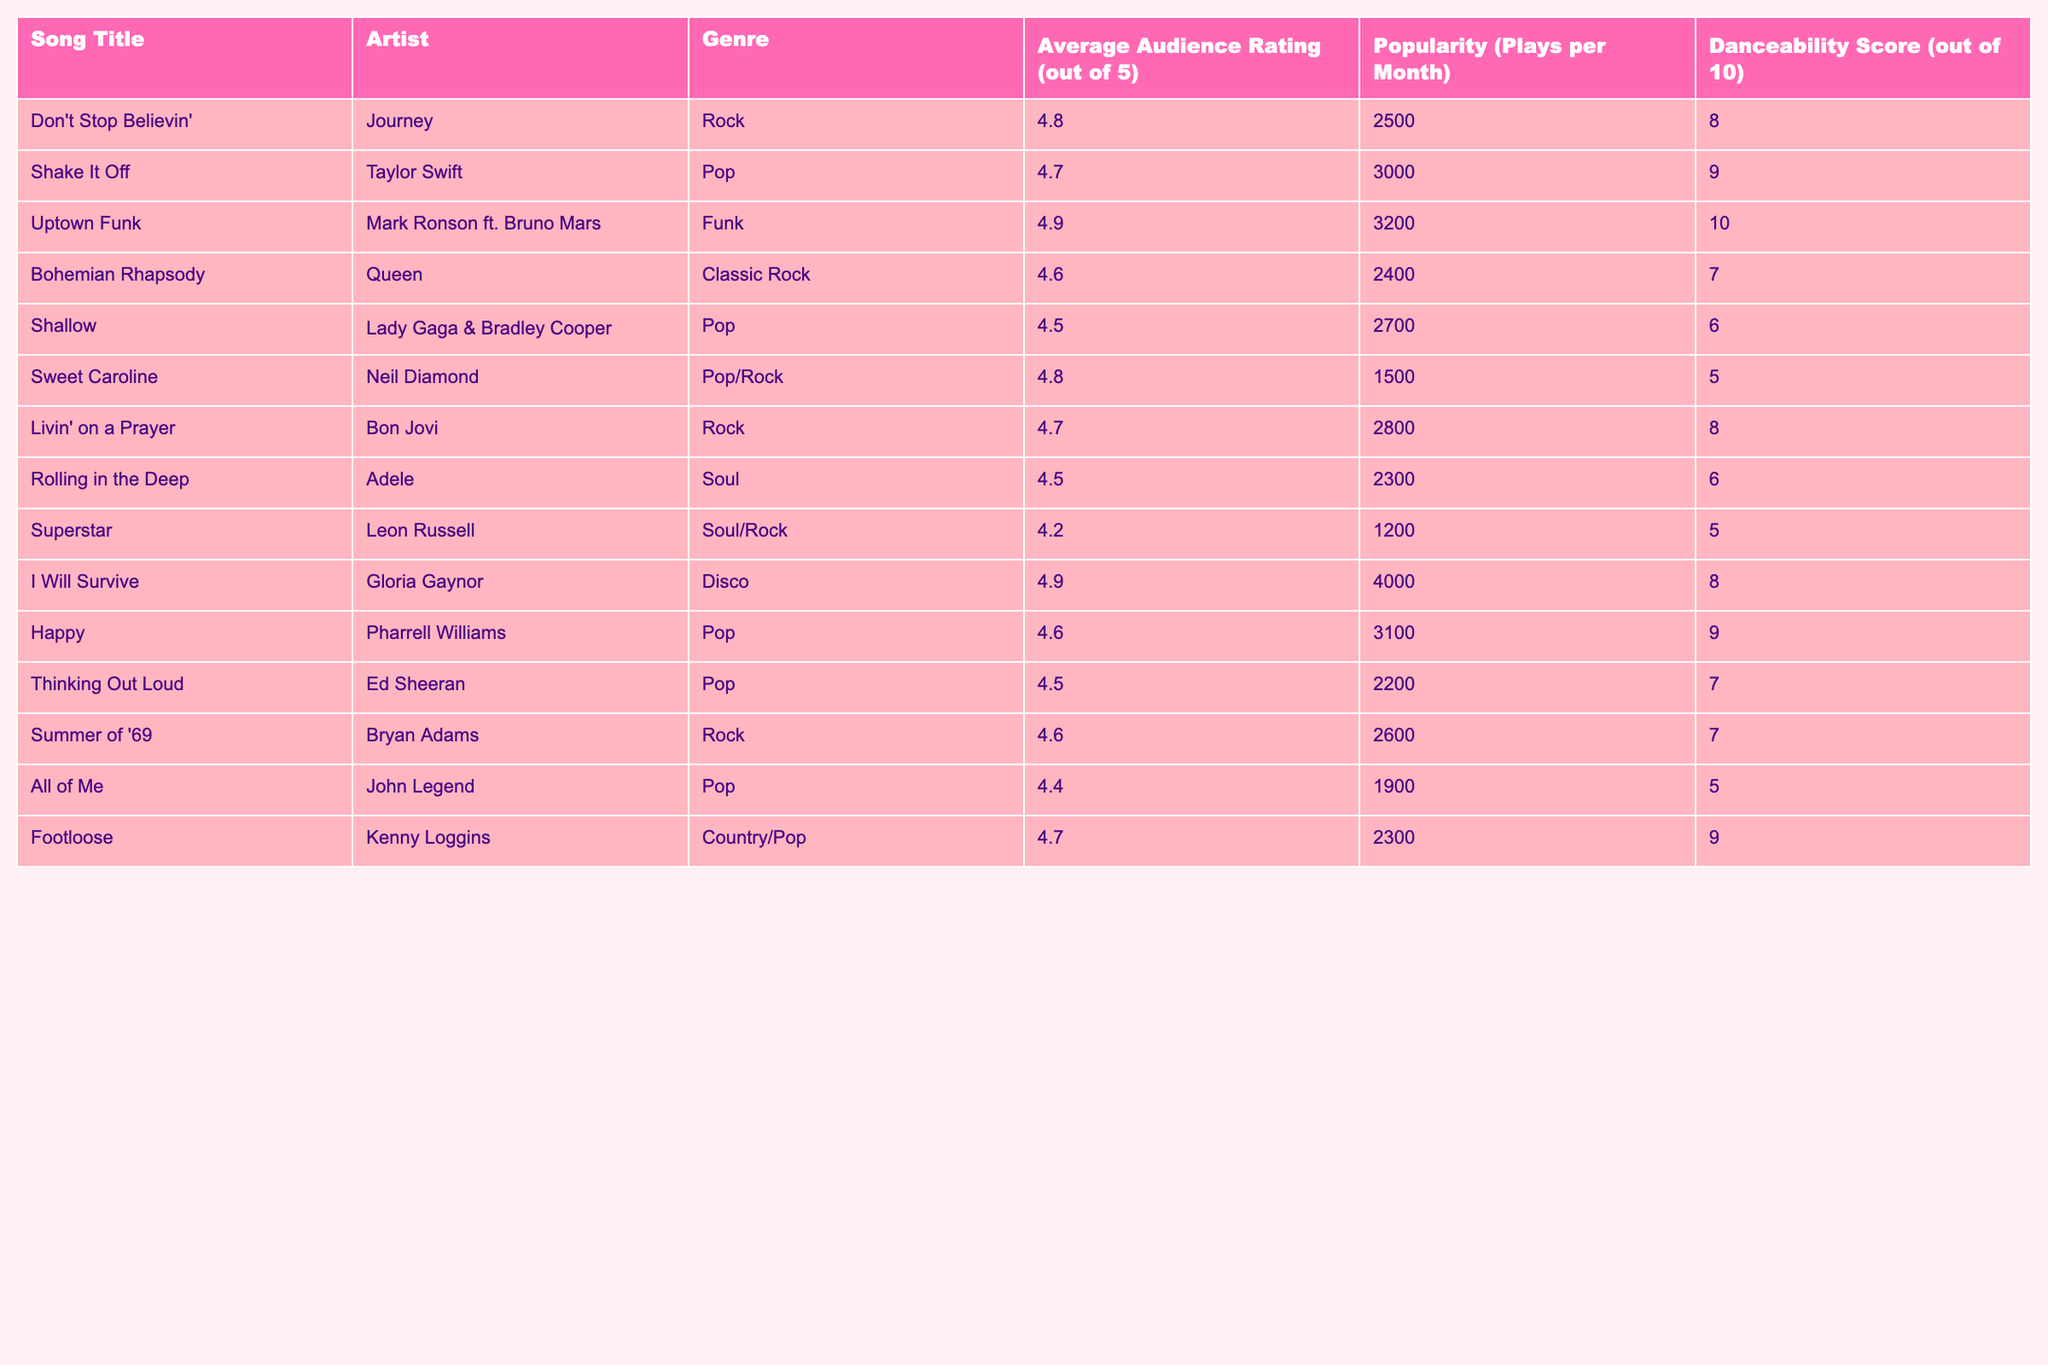What is the average audience rating for "Uptown Funk"? The audience rating for "Uptown Funk" is found under the "Average Audience Rating" column. The value listed is 4.9.
Answer: 4.9 Which song has the highest Danceability Score? In the "Danceability Score" column, "Uptown Funk" has the highest score of 10, which is greater than all other songs listed.
Answer: Uptown Funk What is the total Average Audience Rating for songs in the Pop genre? The Average Audience Ratings for Pop songs are 4.7 ("Shake It Off"), 4.5 ("Shallow"), 4.6 ("Happy"), 4.5 ("Thinking Out Loud"), and 4.4 ("All of Me"). Summing these gives 4.7 + 4.5 + 4.6 + 4.5 + 4.4 = 22.7, and dividing by 5 gives an average rating of 22.7 / 5 = 4.54.
Answer: 4.54 How many songs listed have an average audience rating of 4.6 or higher? By checking the ratings in the "Average Audience Rating" column, we find the songs "Don't Stop Believin'" (4.8), "Uptown Funk" (4.9), "I Will Survive" (4.9), and "Livin' on a Prayer" (4.7) among others. Counting these gives a total of 8 songs with ratings of 4.6 or higher.
Answer: 8 Is "Sweet Caroline" more popular than "Shallow" based on plays per month? "Sweet Caroline" has 1500 plays per month, while "Shallow" has 2700 plays per month. Since 1500 is less than 2700, it indicates that "Sweet Caroline" is less popular than "Shallow."
Answer: No Which genre has the most songs listed in the table? Looking at the genres in each song, we see "Pop" appears 5 times, followed by "Rock" with 4 entries. Thus, Pop has the most occurrences.
Answer: Pop What is the difference in popularity between "I Will Survive" and "Livin' on a Prayer"? "I Will Survive" has a popularity of 4000 plays, while "Livin' on a Prayer" has 2800 plays. The difference is 4000 - 2800 = 1200.
Answer: 1200 Does the genre "Soul" have any songs rated below 4.4? The songs "Rolling in the Deep" has a rating of 4.5, and "Superstar" has a rating of 4.2. Checking reveals that "Superstar" is rated below 4.4.
Answer: Yes Which song has the lowest popularity? In the "Popularity" column, "Superstar" has the lowest value of 1200 plays per month compared to all the other songs.
Answer: Superstar What is the average Danceability Score for Rock songs? The Danceability Scores for Rock songs are 8 ("Don't Stop Believin'"), 8 ("Livin' on a Prayer"), and 7 ("Summer of '69"). Summing these gives 8 + 8 + 7 = 23, and dividing by 3 gives an average of 23 / 3 = 7.67.
Answer: 7.67 